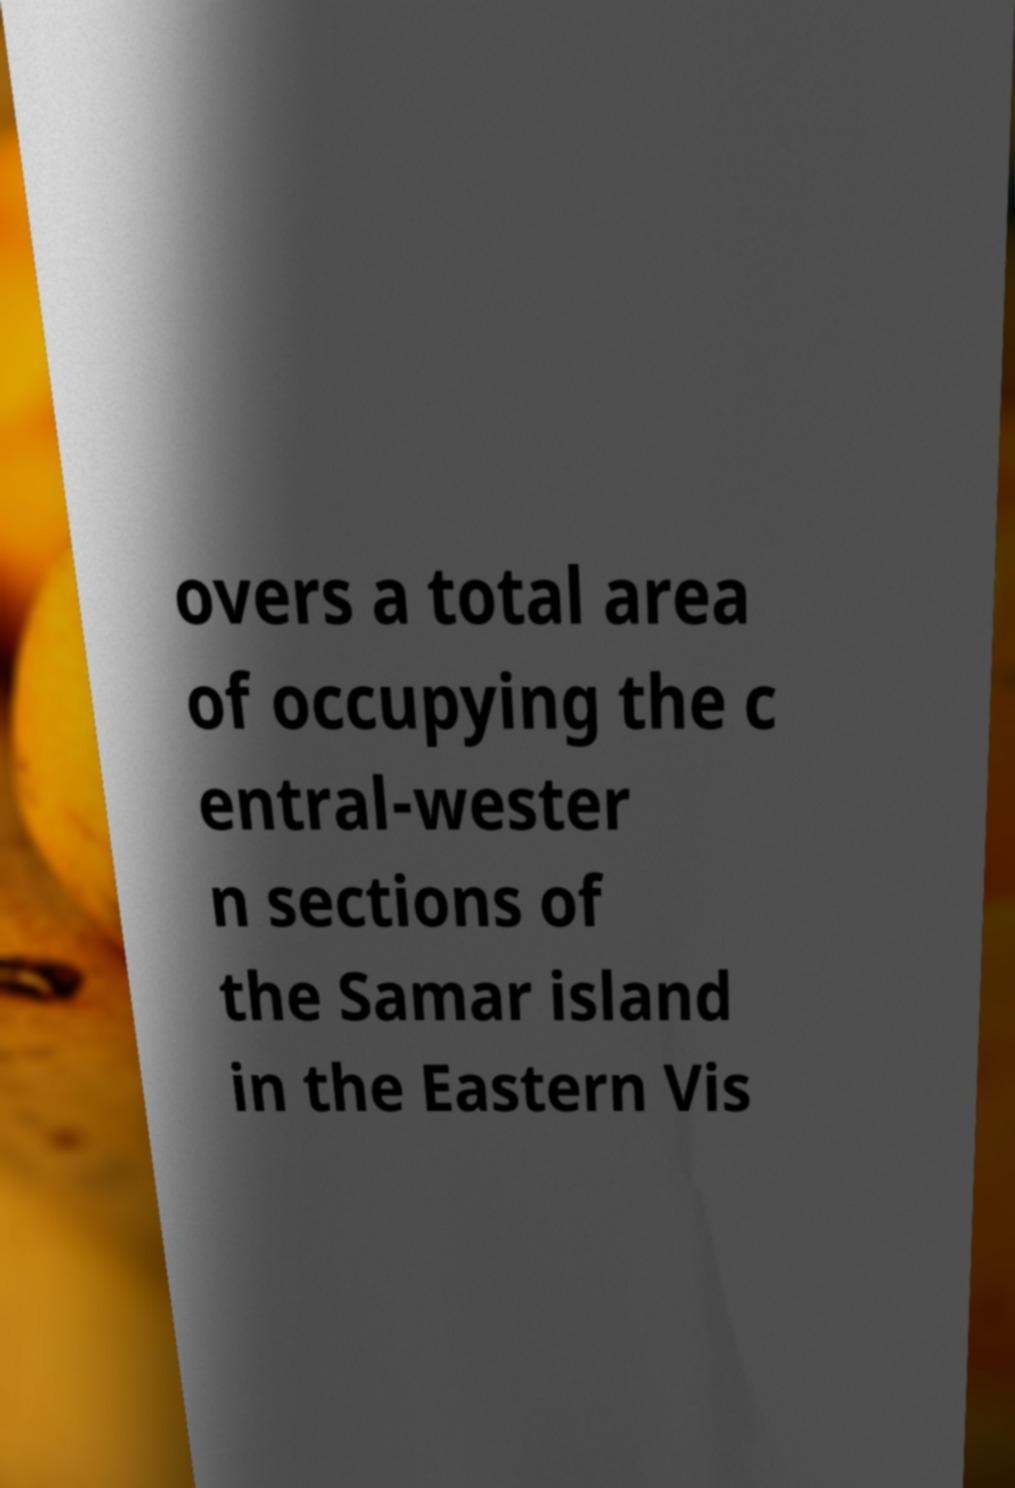Could you extract and type out the text from this image? overs a total area of occupying the c entral-wester n sections of the Samar island in the Eastern Vis 